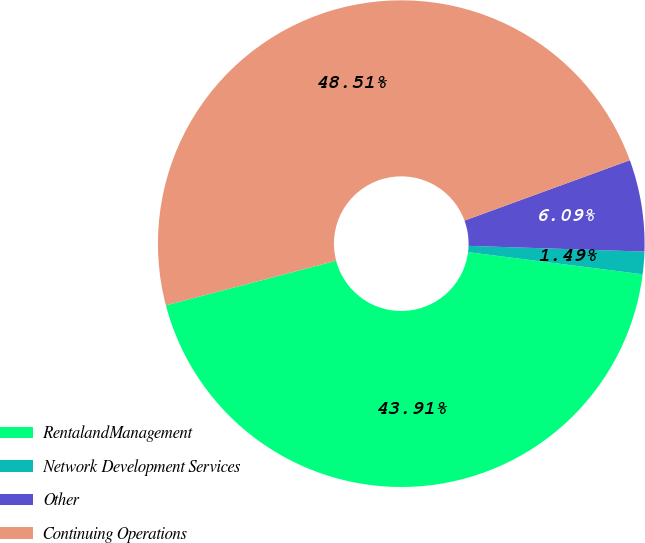Convert chart. <chart><loc_0><loc_0><loc_500><loc_500><pie_chart><fcel>RentalandManagement<fcel>Network Development Services<fcel>Other<fcel>Continuing Operations<nl><fcel>43.91%<fcel>1.49%<fcel>6.09%<fcel>48.51%<nl></chart> 